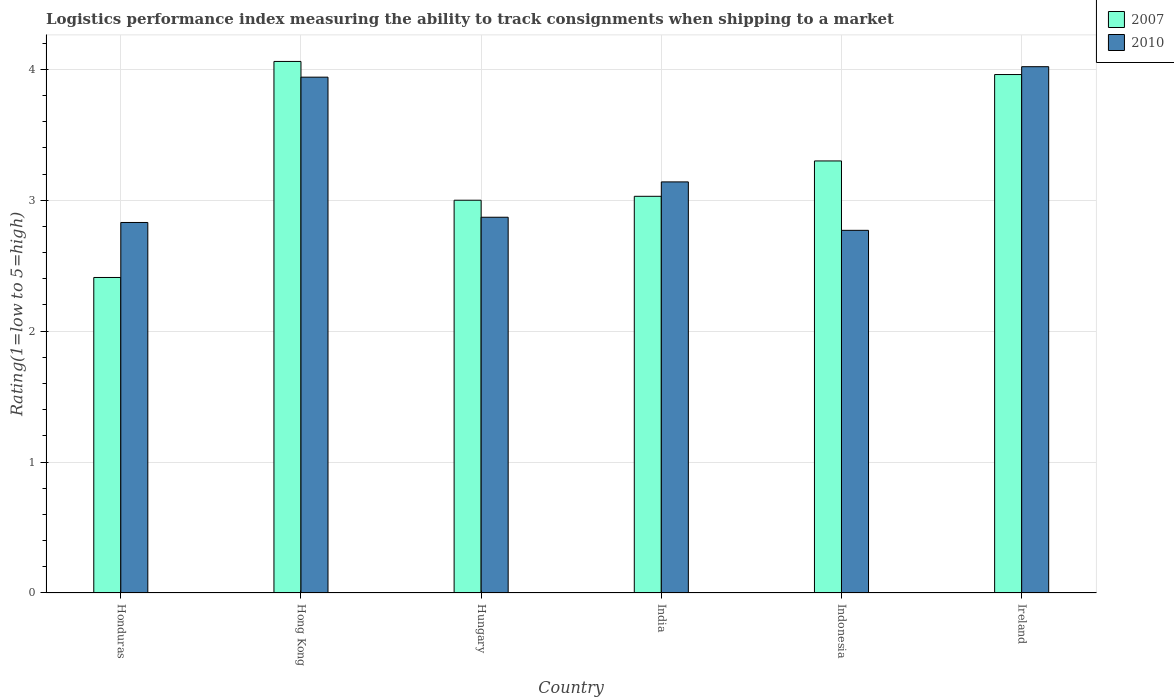How many groups of bars are there?
Your response must be concise. 6. Are the number of bars per tick equal to the number of legend labels?
Offer a terse response. Yes. Are the number of bars on each tick of the X-axis equal?
Your answer should be very brief. Yes. How many bars are there on the 3rd tick from the right?
Offer a terse response. 2. What is the label of the 1st group of bars from the left?
Provide a succinct answer. Honduras. In how many cases, is the number of bars for a given country not equal to the number of legend labels?
Give a very brief answer. 0. What is the Logistic performance index in 2007 in Honduras?
Your answer should be compact. 2.41. Across all countries, what is the maximum Logistic performance index in 2010?
Offer a very short reply. 4.02. Across all countries, what is the minimum Logistic performance index in 2010?
Offer a terse response. 2.77. In which country was the Logistic performance index in 2007 maximum?
Provide a succinct answer. Hong Kong. In which country was the Logistic performance index in 2007 minimum?
Give a very brief answer. Honduras. What is the total Logistic performance index in 2010 in the graph?
Offer a terse response. 19.57. What is the difference between the Logistic performance index in 2007 in Hong Kong and that in India?
Offer a very short reply. 1.03. What is the difference between the Logistic performance index in 2010 in Hungary and the Logistic performance index in 2007 in Ireland?
Your answer should be compact. -1.09. What is the average Logistic performance index in 2007 per country?
Provide a short and direct response. 3.29. What is the difference between the Logistic performance index of/in 2007 and Logistic performance index of/in 2010 in Hong Kong?
Keep it short and to the point. 0.12. In how many countries, is the Logistic performance index in 2007 greater than 2.4?
Your response must be concise. 6. What is the ratio of the Logistic performance index in 2010 in Hungary to that in Ireland?
Ensure brevity in your answer.  0.71. Is the Logistic performance index in 2007 in Hong Kong less than that in Ireland?
Make the answer very short. No. What is the difference between the highest and the second highest Logistic performance index in 2007?
Provide a succinct answer. -0.66. What is the difference between the highest and the lowest Logistic performance index in 2007?
Provide a succinct answer. 1.65. What does the 2nd bar from the left in Honduras represents?
Your answer should be compact. 2010. What does the 2nd bar from the right in Hong Kong represents?
Provide a succinct answer. 2007. How many countries are there in the graph?
Keep it short and to the point. 6. Are the values on the major ticks of Y-axis written in scientific E-notation?
Offer a terse response. No. Does the graph contain any zero values?
Your response must be concise. No. How many legend labels are there?
Your response must be concise. 2. How are the legend labels stacked?
Keep it short and to the point. Vertical. What is the title of the graph?
Provide a short and direct response. Logistics performance index measuring the ability to track consignments when shipping to a market. What is the label or title of the X-axis?
Give a very brief answer. Country. What is the label or title of the Y-axis?
Provide a short and direct response. Rating(1=low to 5=high). What is the Rating(1=low to 5=high) in 2007 in Honduras?
Your answer should be compact. 2.41. What is the Rating(1=low to 5=high) in 2010 in Honduras?
Your response must be concise. 2.83. What is the Rating(1=low to 5=high) of 2007 in Hong Kong?
Your answer should be very brief. 4.06. What is the Rating(1=low to 5=high) in 2010 in Hong Kong?
Give a very brief answer. 3.94. What is the Rating(1=low to 5=high) in 2010 in Hungary?
Offer a terse response. 2.87. What is the Rating(1=low to 5=high) in 2007 in India?
Provide a short and direct response. 3.03. What is the Rating(1=low to 5=high) of 2010 in India?
Keep it short and to the point. 3.14. What is the Rating(1=low to 5=high) of 2007 in Indonesia?
Offer a very short reply. 3.3. What is the Rating(1=low to 5=high) of 2010 in Indonesia?
Provide a short and direct response. 2.77. What is the Rating(1=low to 5=high) in 2007 in Ireland?
Your answer should be very brief. 3.96. What is the Rating(1=low to 5=high) in 2010 in Ireland?
Offer a very short reply. 4.02. Across all countries, what is the maximum Rating(1=low to 5=high) of 2007?
Keep it short and to the point. 4.06. Across all countries, what is the maximum Rating(1=low to 5=high) in 2010?
Give a very brief answer. 4.02. Across all countries, what is the minimum Rating(1=low to 5=high) in 2007?
Give a very brief answer. 2.41. Across all countries, what is the minimum Rating(1=low to 5=high) of 2010?
Provide a succinct answer. 2.77. What is the total Rating(1=low to 5=high) of 2007 in the graph?
Offer a very short reply. 19.76. What is the total Rating(1=low to 5=high) of 2010 in the graph?
Keep it short and to the point. 19.57. What is the difference between the Rating(1=low to 5=high) of 2007 in Honduras and that in Hong Kong?
Ensure brevity in your answer.  -1.65. What is the difference between the Rating(1=low to 5=high) of 2010 in Honduras and that in Hong Kong?
Offer a very short reply. -1.11. What is the difference between the Rating(1=low to 5=high) of 2007 in Honduras and that in Hungary?
Keep it short and to the point. -0.59. What is the difference between the Rating(1=low to 5=high) in 2010 in Honduras and that in Hungary?
Make the answer very short. -0.04. What is the difference between the Rating(1=low to 5=high) of 2007 in Honduras and that in India?
Your answer should be compact. -0.62. What is the difference between the Rating(1=low to 5=high) of 2010 in Honduras and that in India?
Provide a succinct answer. -0.31. What is the difference between the Rating(1=low to 5=high) in 2007 in Honduras and that in Indonesia?
Offer a very short reply. -0.89. What is the difference between the Rating(1=low to 5=high) in 2007 in Honduras and that in Ireland?
Provide a succinct answer. -1.55. What is the difference between the Rating(1=low to 5=high) of 2010 in Honduras and that in Ireland?
Provide a succinct answer. -1.19. What is the difference between the Rating(1=low to 5=high) in 2007 in Hong Kong and that in Hungary?
Your response must be concise. 1.06. What is the difference between the Rating(1=low to 5=high) in 2010 in Hong Kong and that in Hungary?
Your answer should be compact. 1.07. What is the difference between the Rating(1=low to 5=high) in 2007 in Hong Kong and that in India?
Provide a succinct answer. 1.03. What is the difference between the Rating(1=low to 5=high) in 2010 in Hong Kong and that in India?
Give a very brief answer. 0.8. What is the difference between the Rating(1=low to 5=high) in 2007 in Hong Kong and that in Indonesia?
Provide a succinct answer. 0.76. What is the difference between the Rating(1=low to 5=high) of 2010 in Hong Kong and that in Indonesia?
Keep it short and to the point. 1.17. What is the difference between the Rating(1=low to 5=high) in 2007 in Hong Kong and that in Ireland?
Provide a short and direct response. 0.1. What is the difference between the Rating(1=low to 5=high) of 2010 in Hong Kong and that in Ireland?
Ensure brevity in your answer.  -0.08. What is the difference between the Rating(1=low to 5=high) in 2007 in Hungary and that in India?
Offer a terse response. -0.03. What is the difference between the Rating(1=low to 5=high) in 2010 in Hungary and that in India?
Provide a succinct answer. -0.27. What is the difference between the Rating(1=low to 5=high) of 2010 in Hungary and that in Indonesia?
Keep it short and to the point. 0.1. What is the difference between the Rating(1=low to 5=high) of 2007 in Hungary and that in Ireland?
Keep it short and to the point. -0.96. What is the difference between the Rating(1=low to 5=high) in 2010 in Hungary and that in Ireland?
Keep it short and to the point. -1.15. What is the difference between the Rating(1=low to 5=high) in 2007 in India and that in Indonesia?
Your answer should be compact. -0.27. What is the difference between the Rating(1=low to 5=high) of 2010 in India and that in Indonesia?
Your answer should be very brief. 0.37. What is the difference between the Rating(1=low to 5=high) in 2007 in India and that in Ireland?
Provide a short and direct response. -0.93. What is the difference between the Rating(1=low to 5=high) in 2010 in India and that in Ireland?
Offer a terse response. -0.88. What is the difference between the Rating(1=low to 5=high) of 2007 in Indonesia and that in Ireland?
Your answer should be compact. -0.66. What is the difference between the Rating(1=low to 5=high) in 2010 in Indonesia and that in Ireland?
Offer a terse response. -1.25. What is the difference between the Rating(1=low to 5=high) of 2007 in Honduras and the Rating(1=low to 5=high) of 2010 in Hong Kong?
Your answer should be compact. -1.53. What is the difference between the Rating(1=low to 5=high) in 2007 in Honduras and the Rating(1=low to 5=high) in 2010 in Hungary?
Your answer should be compact. -0.46. What is the difference between the Rating(1=low to 5=high) in 2007 in Honduras and the Rating(1=low to 5=high) in 2010 in India?
Your answer should be very brief. -0.73. What is the difference between the Rating(1=low to 5=high) in 2007 in Honduras and the Rating(1=low to 5=high) in 2010 in Indonesia?
Your response must be concise. -0.36. What is the difference between the Rating(1=low to 5=high) of 2007 in Honduras and the Rating(1=low to 5=high) of 2010 in Ireland?
Your answer should be compact. -1.61. What is the difference between the Rating(1=low to 5=high) in 2007 in Hong Kong and the Rating(1=low to 5=high) in 2010 in Hungary?
Your answer should be very brief. 1.19. What is the difference between the Rating(1=low to 5=high) of 2007 in Hong Kong and the Rating(1=low to 5=high) of 2010 in India?
Your answer should be compact. 0.92. What is the difference between the Rating(1=low to 5=high) in 2007 in Hong Kong and the Rating(1=low to 5=high) in 2010 in Indonesia?
Keep it short and to the point. 1.29. What is the difference between the Rating(1=low to 5=high) in 2007 in Hong Kong and the Rating(1=low to 5=high) in 2010 in Ireland?
Ensure brevity in your answer.  0.04. What is the difference between the Rating(1=low to 5=high) of 2007 in Hungary and the Rating(1=low to 5=high) of 2010 in India?
Your response must be concise. -0.14. What is the difference between the Rating(1=low to 5=high) in 2007 in Hungary and the Rating(1=low to 5=high) in 2010 in Indonesia?
Offer a very short reply. 0.23. What is the difference between the Rating(1=low to 5=high) of 2007 in Hungary and the Rating(1=low to 5=high) of 2010 in Ireland?
Make the answer very short. -1.02. What is the difference between the Rating(1=low to 5=high) of 2007 in India and the Rating(1=low to 5=high) of 2010 in Indonesia?
Make the answer very short. 0.26. What is the difference between the Rating(1=low to 5=high) in 2007 in India and the Rating(1=low to 5=high) in 2010 in Ireland?
Ensure brevity in your answer.  -0.99. What is the difference between the Rating(1=low to 5=high) of 2007 in Indonesia and the Rating(1=low to 5=high) of 2010 in Ireland?
Make the answer very short. -0.72. What is the average Rating(1=low to 5=high) in 2007 per country?
Offer a very short reply. 3.29. What is the average Rating(1=low to 5=high) of 2010 per country?
Make the answer very short. 3.26. What is the difference between the Rating(1=low to 5=high) of 2007 and Rating(1=low to 5=high) of 2010 in Honduras?
Provide a succinct answer. -0.42. What is the difference between the Rating(1=low to 5=high) in 2007 and Rating(1=low to 5=high) in 2010 in Hong Kong?
Offer a terse response. 0.12. What is the difference between the Rating(1=low to 5=high) in 2007 and Rating(1=low to 5=high) in 2010 in Hungary?
Offer a terse response. 0.13. What is the difference between the Rating(1=low to 5=high) in 2007 and Rating(1=low to 5=high) in 2010 in India?
Keep it short and to the point. -0.11. What is the difference between the Rating(1=low to 5=high) in 2007 and Rating(1=low to 5=high) in 2010 in Indonesia?
Give a very brief answer. 0.53. What is the difference between the Rating(1=low to 5=high) in 2007 and Rating(1=low to 5=high) in 2010 in Ireland?
Provide a short and direct response. -0.06. What is the ratio of the Rating(1=low to 5=high) of 2007 in Honduras to that in Hong Kong?
Your answer should be compact. 0.59. What is the ratio of the Rating(1=low to 5=high) of 2010 in Honduras to that in Hong Kong?
Offer a very short reply. 0.72. What is the ratio of the Rating(1=low to 5=high) of 2007 in Honduras to that in Hungary?
Your answer should be very brief. 0.8. What is the ratio of the Rating(1=low to 5=high) of 2010 in Honduras to that in Hungary?
Ensure brevity in your answer.  0.99. What is the ratio of the Rating(1=low to 5=high) in 2007 in Honduras to that in India?
Provide a succinct answer. 0.8. What is the ratio of the Rating(1=low to 5=high) of 2010 in Honduras to that in India?
Your response must be concise. 0.9. What is the ratio of the Rating(1=low to 5=high) in 2007 in Honduras to that in Indonesia?
Ensure brevity in your answer.  0.73. What is the ratio of the Rating(1=low to 5=high) in 2010 in Honduras to that in Indonesia?
Ensure brevity in your answer.  1.02. What is the ratio of the Rating(1=low to 5=high) in 2007 in Honduras to that in Ireland?
Your answer should be compact. 0.61. What is the ratio of the Rating(1=low to 5=high) in 2010 in Honduras to that in Ireland?
Your response must be concise. 0.7. What is the ratio of the Rating(1=low to 5=high) in 2007 in Hong Kong to that in Hungary?
Keep it short and to the point. 1.35. What is the ratio of the Rating(1=low to 5=high) in 2010 in Hong Kong to that in Hungary?
Ensure brevity in your answer.  1.37. What is the ratio of the Rating(1=low to 5=high) in 2007 in Hong Kong to that in India?
Provide a succinct answer. 1.34. What is the ratio of the Rating(1=low to 5=high) of 2010 in Hong Kong to that in India?
Provide a short and direct response. 1.25. What is the ratio of the Rating(1=low to 5=high) of 2007 in Hong Kong to that in Indonesia?
Your answer should be compact. 1.23. What is the ratio of the Rating(1=low to 5=high) of 2010 in Hong Kong to that in Indonesia?
Your response must be concise. 1.42. What is the ratio of the Rating(1=low to 5=high) in 2007 in Hong Kong to that in Ireland?
Offer a terse response. 1.03. What is the ratio of the Rating(1=low to 5=high) in 2010 in Hong Kong to that in Ireland?
Give a very brief answer. 0.98. What is the ratio of the Rating(1=low to 5=high) of 2007 in Hungary to that in India?
Your answer should be very brief. 0.99. What is the ratio of the Rating(1=low to 5=high) in 2010 in Hungary to that in India?
Provide a short and direct response. 0.91. What is the ratio of the Rating(1=low to 5=high) of 2010 in Hungary to that in Indonesia?
Offer a terse response. 1.04. What is the ratio of the Rating(1=low to 5=high) of 2007 in Hungary to that in Ireland?
Provide a succinct answer. 0.76. What is the ratio of the Rating(1=low to 5=high) of 2010 in Hungary to that in Ireland?
Your answer should be very brief. 0.71. What is the ratio of the Rating(1=low to 5=high) of 2007 in India to that in Indonesia?
Make the answer very short. 0.92. What is the ratio of the Rating(1=low to 5=high) in 2010 in India to that in Indonesia?
Provide a succinct answer. 1.13. What is the ratio of the Rating(1=low to 5=high) in 2007 in India to that in Ireland?
Your answer should be very brief. 0.77. What is the ratio of the Rating(1=low to 5=high) in 2010 in India to that in Ireland?
Your answer should be very brief. 0.78. What is the ratio of the Rating(1=low to 5=high) in 2007 in Indonesia to that in Ireland?
Your answer should be very brief. 0.83. What is the ratio of the Rating(1=low to 5=high) of 2010 in Indonesia to that in Ireland?
Give a very brief answer. 0.69. What is the difference between the highest and the lowest Rating(1=low to 5=high) in 2007?
Give a very brief answer. 1.65. What is the difference between the highest and the lowest Rating(1=low to 5=high) in 2010?
Provide a succinct answer. 1.25. 